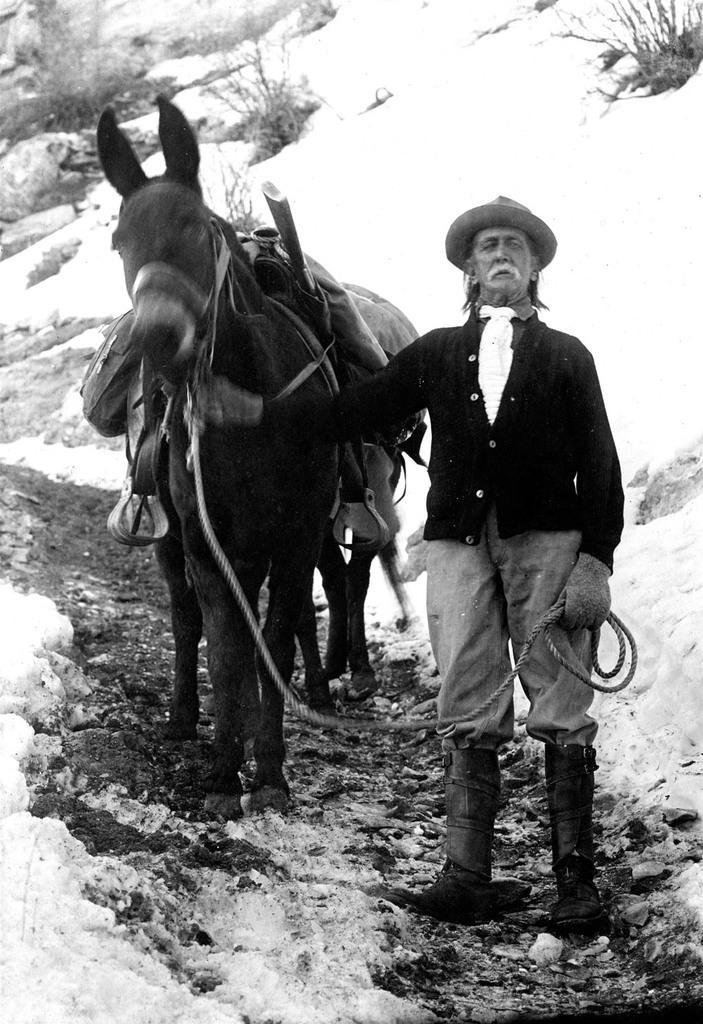In one or two sentences, can you explain what this image depicts? This picture is clicked outside. On the right there is a man holding a rope which is tied to an animal seems to be the horse and both of them are standing on the ground. In the background we can see the dry stems and the rocks. 